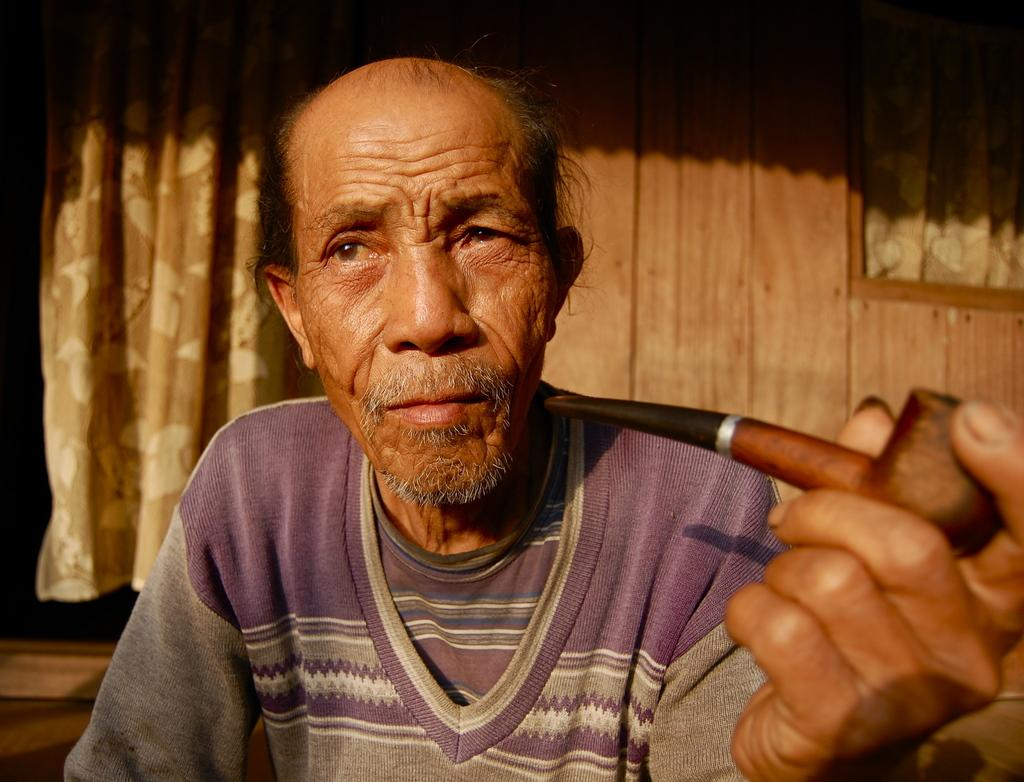What is the main subject of the image? There is a person in the image. What is the person holding in their hand? The person is holding a smoking pipe with one hand. What can be seen in the background of the image? There is a curtain and a wooden wall in the background of the image. Can you describe the wooden wall in the image? The wooden wall has a window. What flavor of porter is the person drinking in the image? There is no drink or mention of porter in the image; the person is holding a smoking pipe. How does the rain affect the person in the image? There is no rain present in the image; it is not mentioned or depicted. 